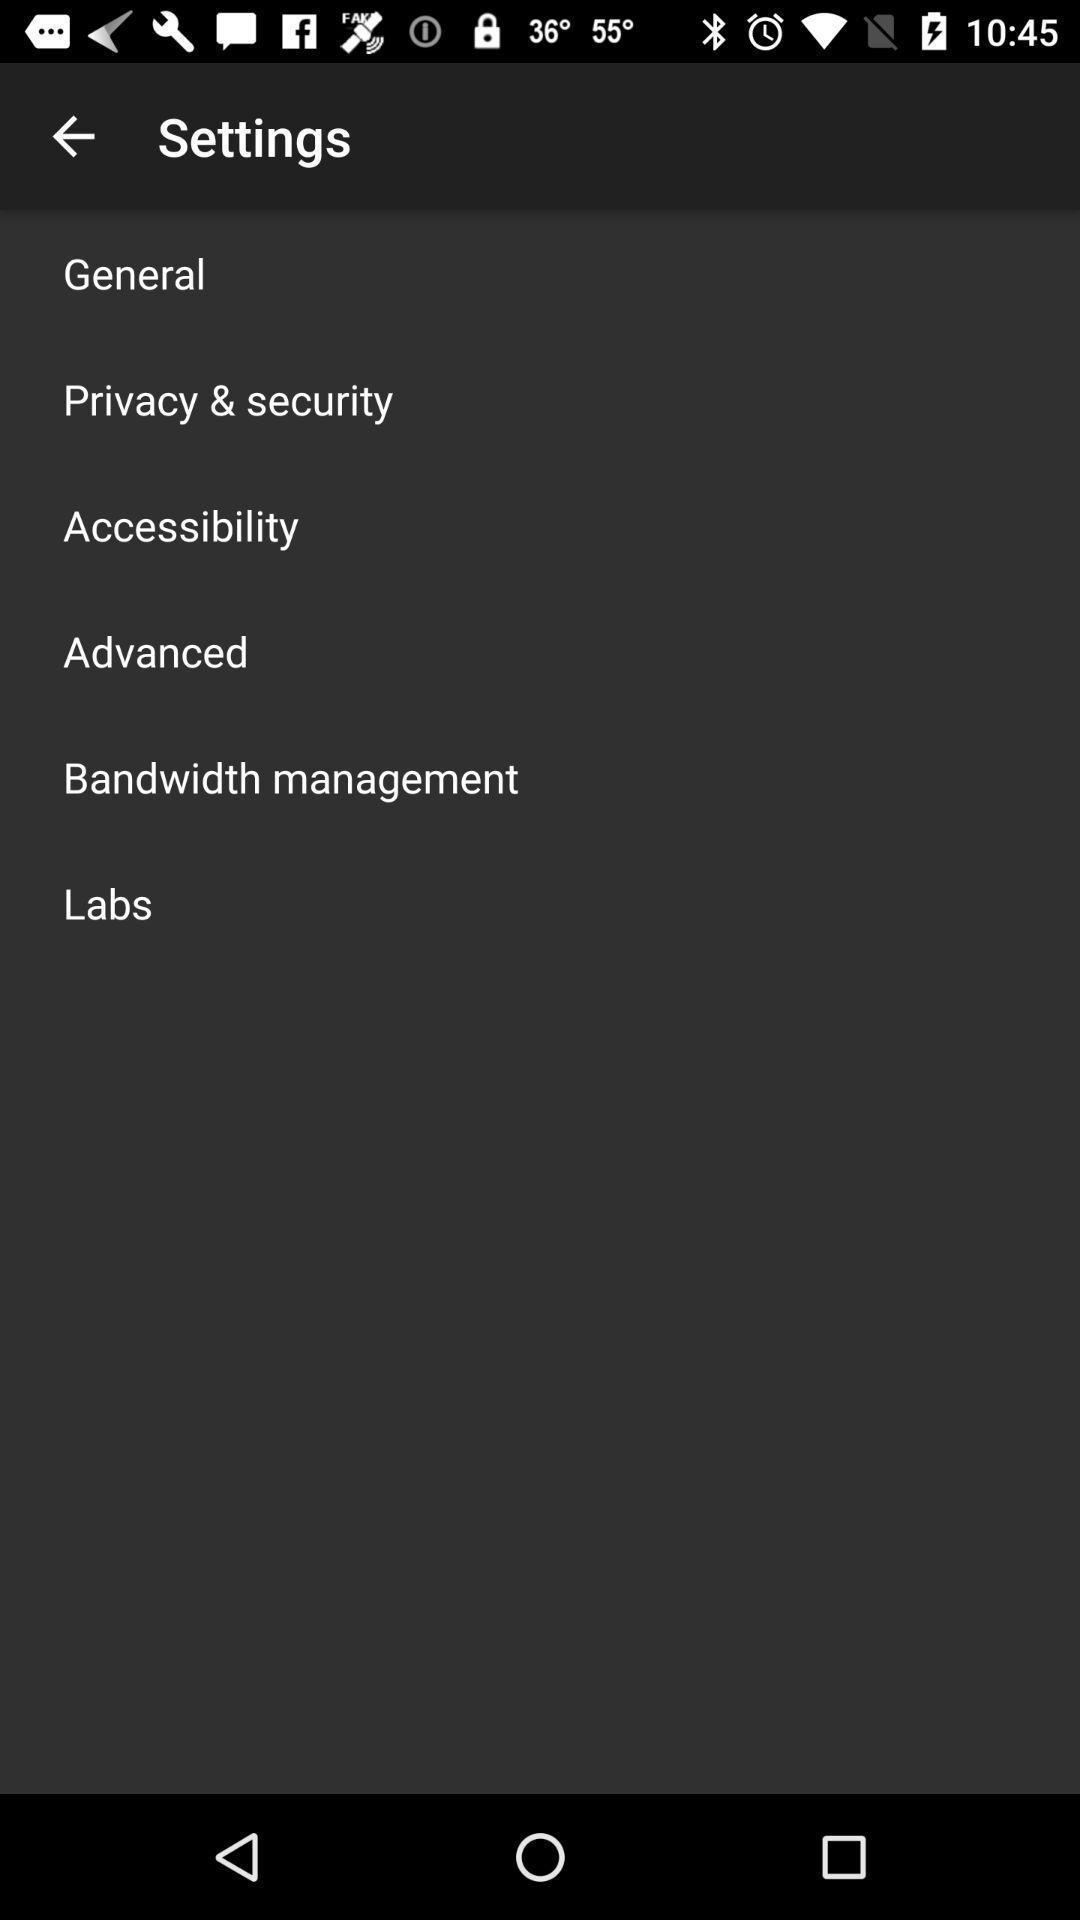Provide a textual representation of this image. Settings page with various options. 